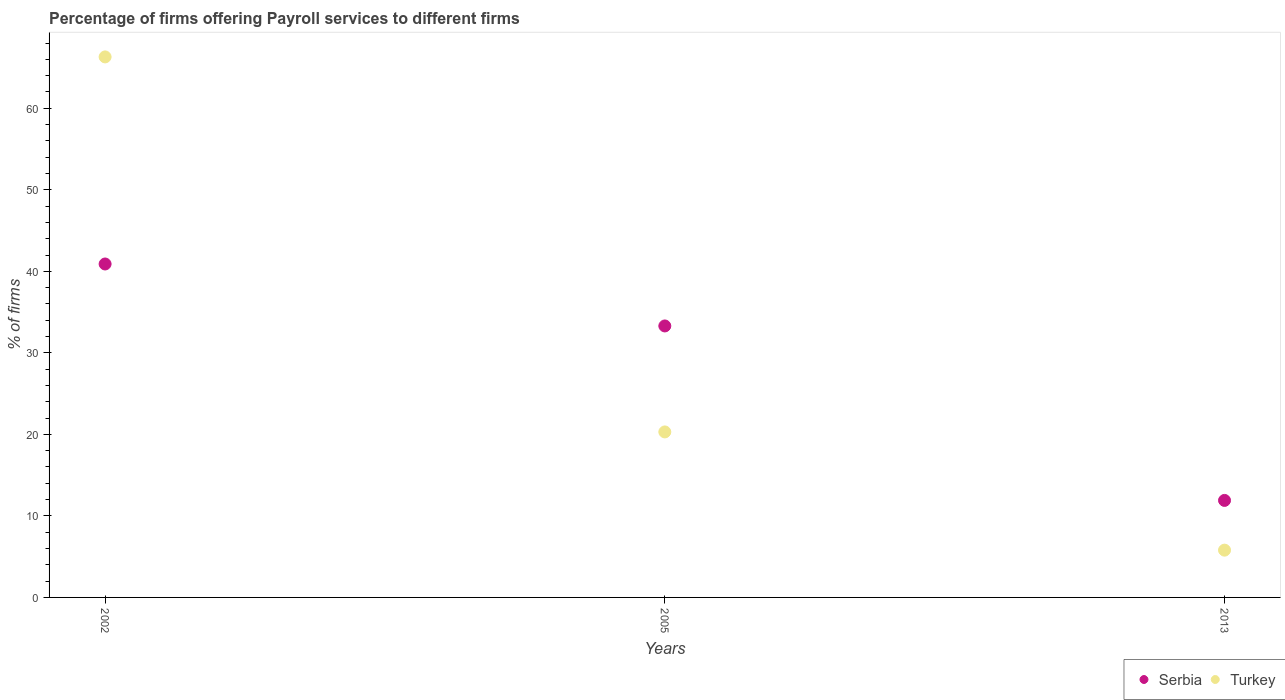How many different coloured dotlines are there?
Offer a very short reply. 2. What is the percentage of firms offering payroll services in Serbia in 2013?
Provide a succinct answer. 11.9. Across all years, what is the maximum percentage of firms offering payroll services in Serbia?
Offer a terse response. 40.9. Across all years, what is the minimum percentage of firms offering payroll services in Serbia?
Offer a terse response. 11.9. In which year was the percentage of firms offering payroll services in Serbia maximum?
Your answer should be compact. 2002. What is the total percentage of firms offering payroll services in Turkey in the graph?
Offer a very short reply. 92.4. What is the difference between the percentage of firms offering payroll services in Serbia in 2005 and that in 2013?
Provide a short and direct response. 21.4. What is the difference between the percentage of firms offering payroll services in Turkey in 2002 and the percentage of firms offering payroll services in Serbia in 2013?
Make the answer very short. 54.4. What is the average percentage of firms offering payroll services in Serbia per year?
Your answer should be very brief. 28.7. In the year 2013, what is the difference between the percentage of firms offering payroll services in Turkey and percentage of firms offering payroll services in Serbia?
Offer a very short reply. -6.1. In how many years, is the percentage of firms offering payroll services in Turkey greater than 30 %?
Provide a short and direct response. 1. What is the ratio of the percentage of firms offering payroll services in Serbia in 2002 to that in 2013?
Keep it short and to the point. 3.44. Is the difference between the percentage of firms offering payroll services in Turkey in 2005 and 2013 greater than the difference between the percentage of firms offering payroll services in Serbia in 2005 and 2013?
Offer a very short reply. No. What is the difference between the highest and the lowest percentage of firms offering payroll services in Turkey?
Keep it short and to the point. 60.5. In how many years, is the percentage of firms offering payroll services in Serbia greater than the average percentage of firms offering payroll services in Serbia taken over all years?
Your answer should be very brief. 2. Is the sum of the percentage of firms offering payroll services in Turkey in 2002 and 2013 greater than the maximum percentage of firms offering payroll services in Serbia across all years?
Your answer should be compact. Yes. Is the percentage of firms offering payroll services in Turkey strictly greater than the percentage of firms offering payroll services in Serbia over the years?
Provide a short and direct response. No. Is the percentage of firms offering payroll services in Turkey strictly less than the percentage of firms offering payroll services in Serbia over the years?
Your answer should be very brief. No. How many years are there in the graph?
Offer a terse response. 3. What is the difference between two consecutive major ticks on the Y-axis?
Ensure brevity in your answer.  10. How many legend labels are there?
Provide a succinct answer. 2. What is the title of the graph?
Your answer should be compact. Percentage of firms offering Payroll services to different firms. What is the label or title of the Y-axis?
Provide a succinct answer. % of firms. What is the % of firms in Serbia in 2002?
Offer a terse response. 40.9. What is the % of firms in Turkey in 2002?
Offer a terse response. 66.3. What is the % of firms in Serbia in 2005?
Make the answer very short. 33.3. What is the % of firms in Turkey in 2005?
Keep it short and to the point. 20.3. What is the % of firms of Serbia in 2013?
Keep it short and to the point. 11.9. Across all years, what is the maximum % of firms of Serbia?
Offer a very short reply. 40.9. Across all years, what is the maximum % of firms in Turkey?
Provide a short and direct response. 66.3. What is the total % of firms of Serbia in the graph?
Your answer should be very brief. 86.1. What is the total % of firms of Turkey in the graph?
Your answer should be very brief. 92.4. What is the difference between the % of firms of Serbia in 2002 and that in 2005?
Provide a short and direct response. 7.6. What is the difference between the % of firms in Turkey in 2002 and that in 2005?
Provide a succinct answer. 46. What is the difference between the % of firms in Serbia in 2002 and that in 2013?
Give a very brief answer. 29. What is the difference between the % of firms in Turkey in 2002 and that in 2013?
Give a very brief answer. 60.5. What is the difference between the % of firms in Serbia in 2005 and that in 2013?
Your answer should be compact. 21.4. What is the difference between the % of firms of Turkey in 2005 and that in 2013?
Offer a terse response. 14.5. What is the difference between the % of firms in Serbia in 2002 and the % of firms in Turkey in 2005?
Keep it short and to the point. 20.6. What is the difference between the % of firms in Serbia in 2002 and the % of firms in Turkey in 2013?
Your answer should be compact. 35.1. What is the average % of firms in Serbia per year?
Your answer should be very brief. 28.7. What is the average % of firms in Turkey per year?
Provide a succinct answer. 30.8. In the year 2002, what is the difference between the % of firms of Serbia and % of firms of Turkey?
Provide a short and direct response. -25.4. In the year 2013, what is the difference between the % of firms of Serbia and % of firms of Turkey?
Provide a short and direct response. 6.1. What is the ratio of the % of firms of Serbia in 2002 to that in 2005?
Offer a very short reply. 1.23. What is the ratio of the % of firms in Turkey in 2002 to that in 2005?
Keep it short and to the point. 3.27. What is the ratio of the % of firms in Serbia in 2002 to that in 2013?
Provide a short and direct response. 3.44. What is the ratio of the % of firms in Turkey in 2002 to that in 2013?
Ensure brevity in your answer.  11.43. What is the ratio of the % of firms in Serbia in 2005 to that in 2013?
Make the answer very short. 2.8. What is the difference between the highest and the second highest % of firms of Serbia?
Your answer should be compact. 7.6. What is the difference between the highest and the lowest % of firms in Turkey?
Offer a terse response. 60.5. 